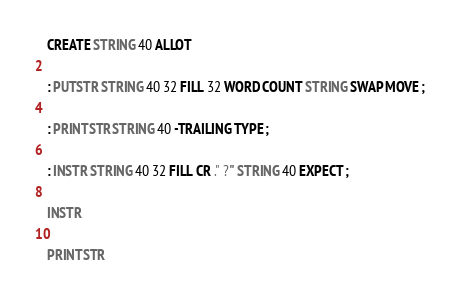Convert code to text. <code><loc_0><loc_0><loc_500><loc_500><_Forth_>CREATE STRING 40 ALLOT

: PUTSTR STRING 40 32 FILL 32 WORD COUNT STRING SWAP MOVE ;

: PRINTSTR STRING 40 -TRAILING TYPE ;

: INSTR STRING 40 32 FILL CR ." ?" STRING 40 EXPECT ;

INSTR

PRINTSTR
</code> 